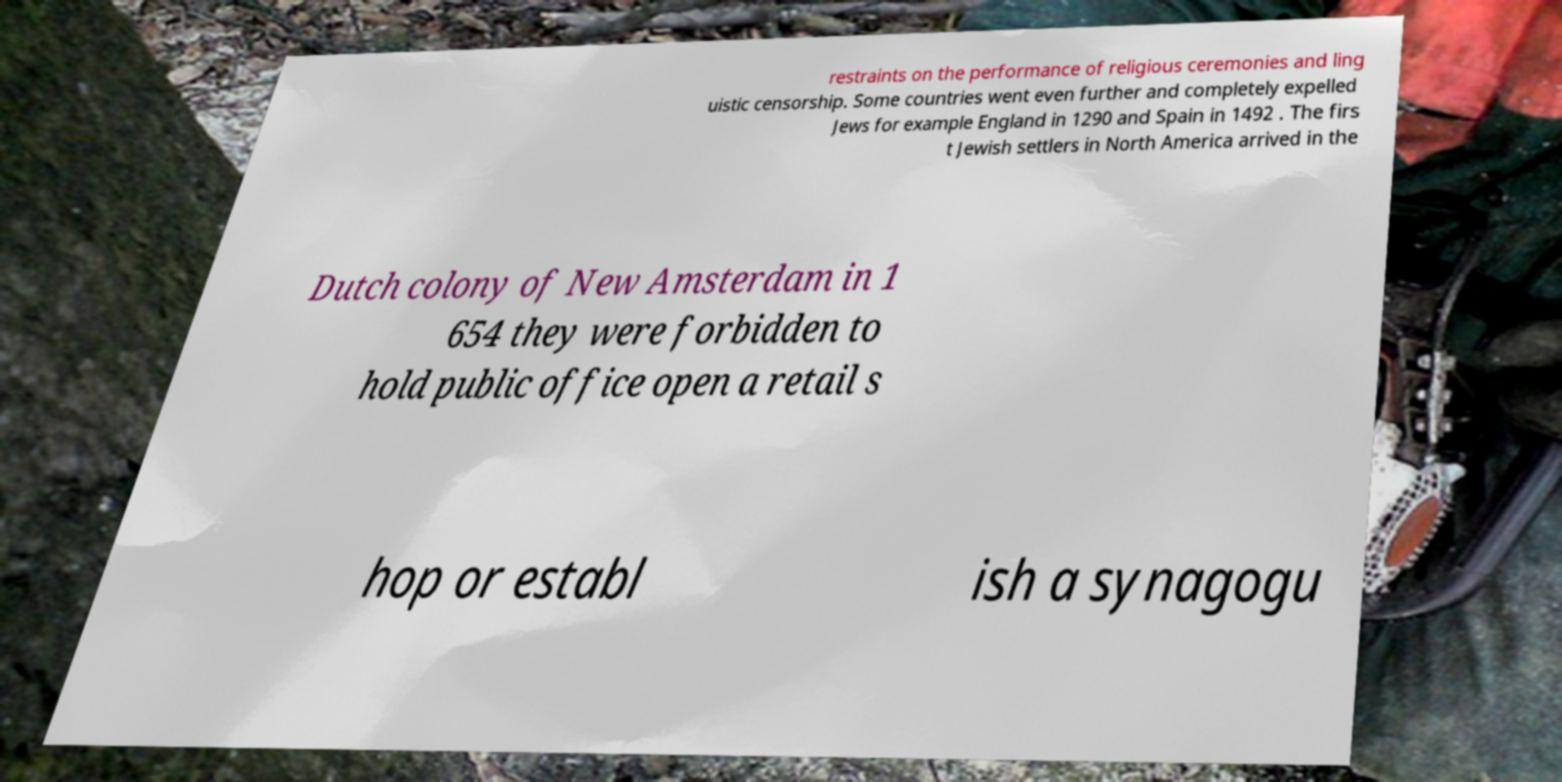Can you read and provide the text displayed in the image?This photo seems to have some interesting text. Can you extract and type it out for me? restraints on the performance of religious ceremonies and ling uistic censorship. Some countries went even further and completely expelled Jews for example England in 1290 and Spain in 1492 . The firs t Jewish settlers in North America arrived in the Dutch colony of New Amsterdam in 1 654 they were forbidden to hold public office open a retail s hop or establ ish a synagogu 